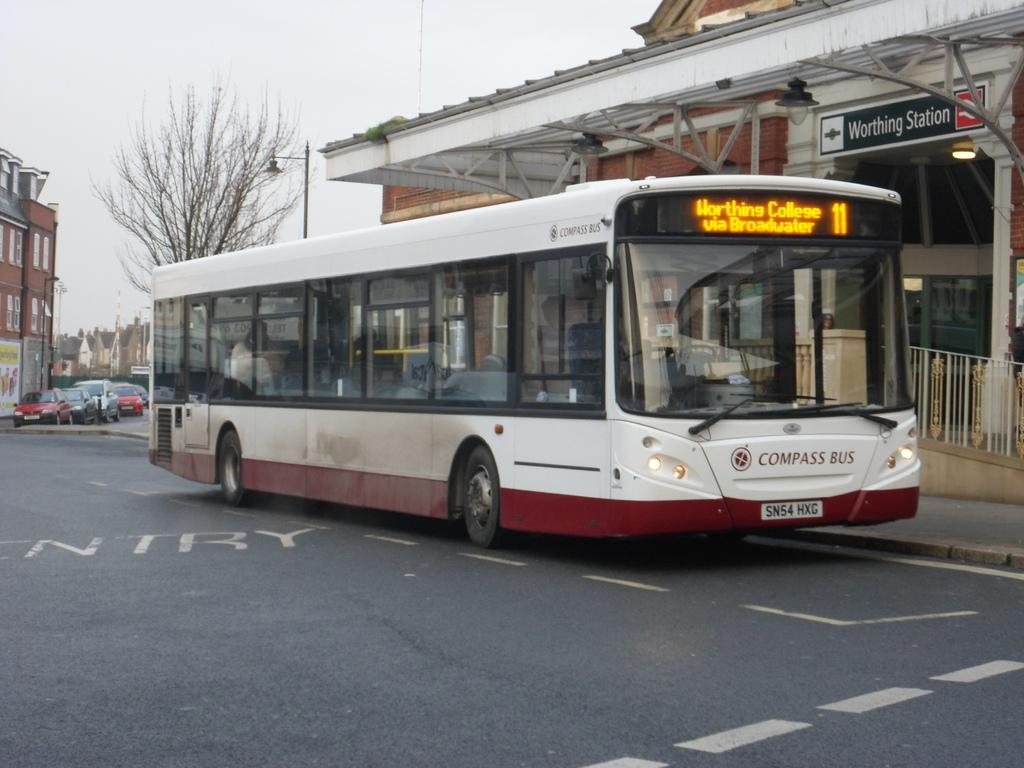<image>
Provide a brief description of the given image. The white and red bus shown is a number 11 bus. 